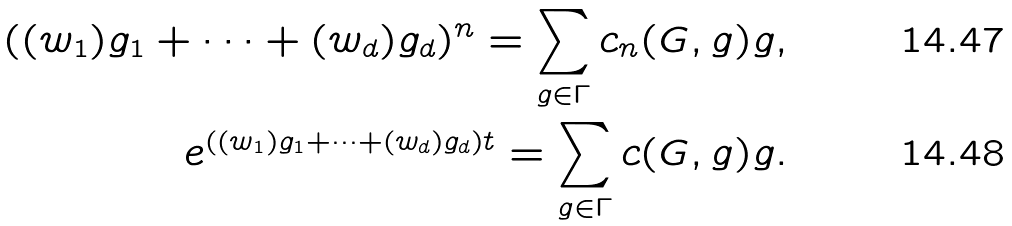<formula> <loc_0><loc_0><loc_500><loc_500>( ( w _ { 1 } ) g _ { 1 } + \dots + ( w _ { d } ) g _ { d } ) ^ { n } = \sum _ { g \in \Gamma } c _ { n } ( G , g ) g , \\ e ^ { ( ( w _ { 1 } ) g _ { 1 } + \dots + ( w _ { d } ) g _ { d } ) t } = \sum _ { g \in \Gamma } c ( G , g ) g .</formula> 